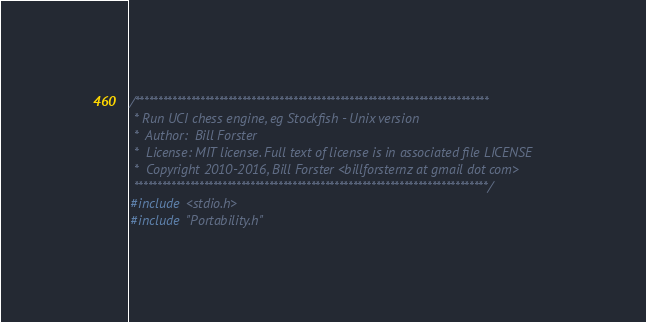<code> <loc_0><loc_0><loc_500><loc_500><_C++_>/****************************************************************************
 * Run UCI chess engine, eg Stockfish - Unix version
 *  Author:  Bill Forster
 *  License: MIT license. Full text of license is in associated file LICENSE
 *  Copyright 2010-2016, Bill Forster <billforsternz at gmail dot com>
 ****************************************************************************/
#include <stdio.h>
#include "Portability.h"
</code> 